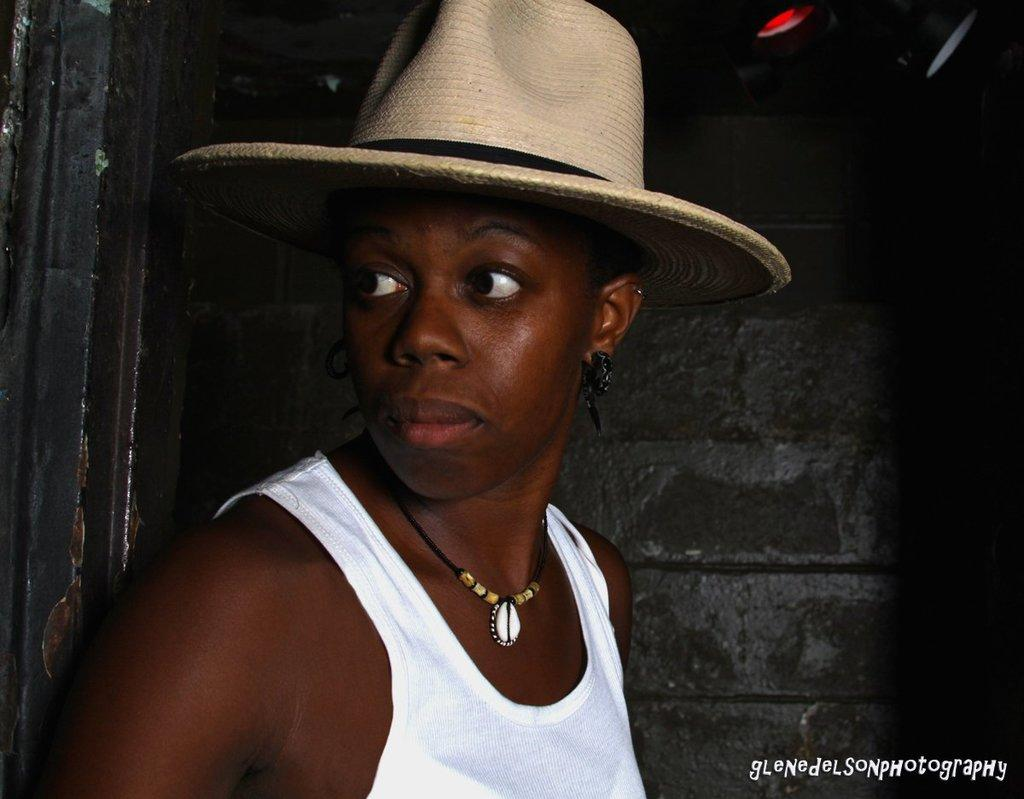Who is present in the image? There is a woman in the image. What is the woman doing or standing over in the image? The woman is present over a place. What is the woman wearing on her head in the image? The woman is wearing a hat. What type of vegetable is the woman holding in the image? There is no vegetable present in the image; the woman is wearing a hat. 